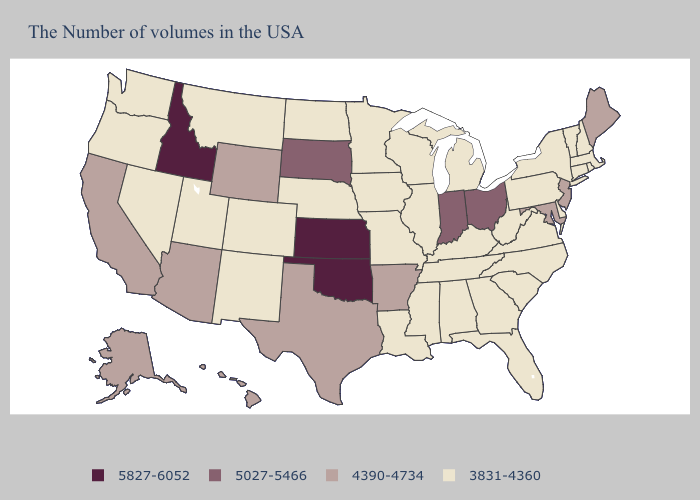Name the states that have a value in the range 5027-5466?
Quick response, please. Ohio, Indiana, South Dakota. Among the states that border Wyoming , which have the lowest value?
Be succinct. Nebraska, Colorado, Utah, Montana. Which states have the lowest value in the Northeast?
Give a very brief answer. Massachusetts, Rhode Island, New Hampshire, Vermont, Connecticut, New York, Pennsylvania. Name the states that have a value in the range 5027-5466?
Short answer required. Ohio, Indiana, South Dakota. Does the first symbol in the legend represent the smallest category?
Give a very brief answer. No. What is the highest value in states that border Louisiana?
Answer briefly. 4390-4734. Which states have the lowest value in the Northeast?
Write a very short answer. Massachusetts, Rhode Island, New Hampshire, Vermont, Connecticut, New York, Pennsylvania. Name the states that have a value in the range 4390-4734?
Quick response, please. Maine, New Jersey, Maryland, Arkansas, Texas, Wyoming, Arizona, California, Alaska, Hawaii. What is the value of Kentucky?
Concise answer only. 3831-4360. What is the lowest value in the USA?
Quick response, please. 3831-4360. What is the lowest value in the Northeast?
Write a very short answer. 3831-4360. Among the states that border New Jersey , which have the lowest value?
Give a very brief answer. New York, Delaware, Pennsylvania. Which states have the highest value in the USA?
Write a very short answer. Kansas, Oklahoma, Idaho. Does Delaware have a lower value than Maine?
Give a very brief answer. Yes. Name the states that have a value in the range 5027-5466?
Keep it brief. Ohio, Indiana, South Dakota. 